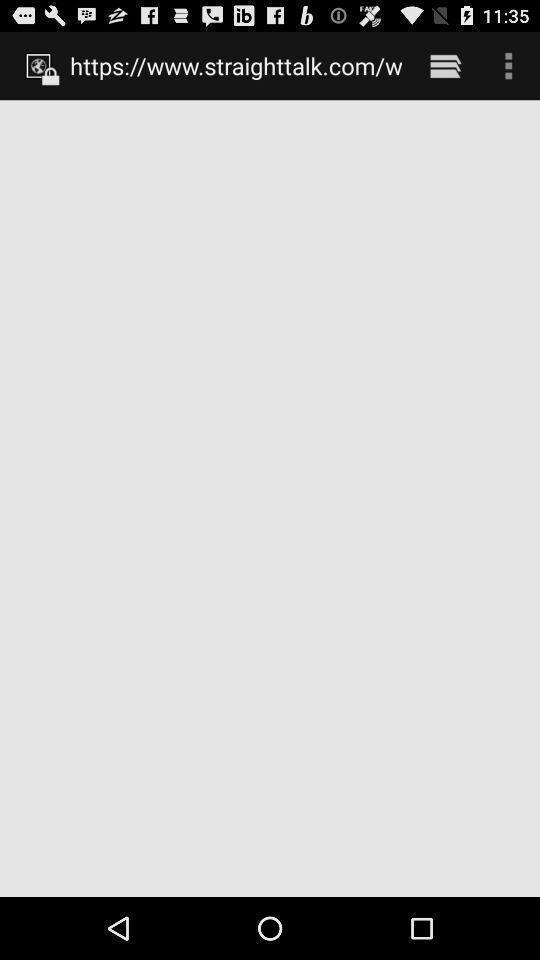Tell me what you see in this picture. Screen displays the link of the some site in application. 